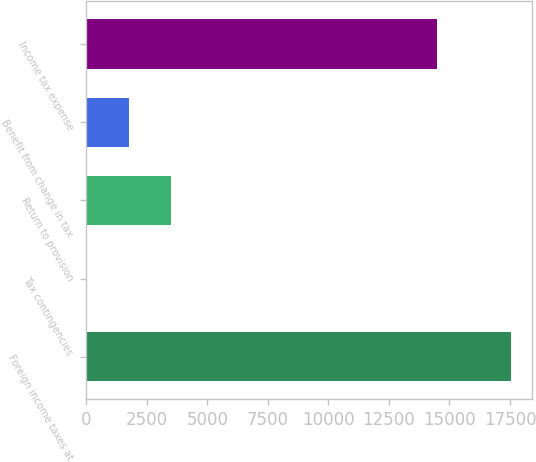<chart> <loc_0><loc_0><loc_500><loc_500><bar_chart><fcel>Foreign income taxes at<fcel>Tax contingencies<fcel>Return to provision<fcel>Benefit from change in tax<fcel>Income tax expense<nl><fcel>17540<fcel>5<fcel>3512<fcel>1758.5<fcel>14467<nl></chart> 